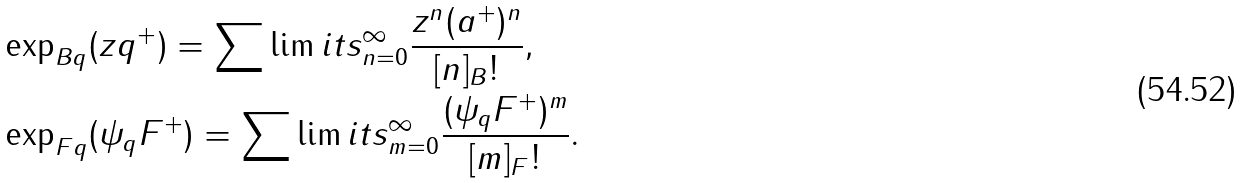<formula> <loc_0><loc_0><loc_500><loc_500>& \exp _ { B q } ( z q ^ { + } ) = \sum \lim i t s _ { n = 0 } ^ { \infty } { \frac { z ^ { n } ( a ^ { + } ) ^ { n } } { [ n ] _ { B } ! } } , \\ & \exp _ { F q } ( \psi _ { q } F ^ { + } ) = \sum \lim i t s _ { m = 0 } ^ { \infty } { \frac { ( \psi _ { q } F ^ { + } ) ^ { m } } { [ m ] _ { F } ! } } .</formula> 